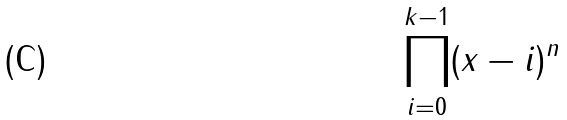Convert formula to latex. <formula><loc_0><loc_0><loc_500><loc_500>\prod _ { i = 0 } ^ { k - 1 } ( x - i ) ^ { n }</formula> 